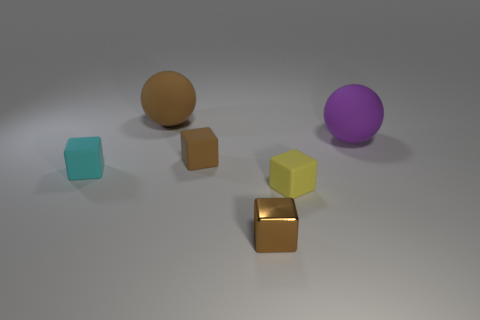Subtract 1 blocks. How many blocks are left? 3 Subtract all gray cubes. Subtract all gray spheres. How many cubes are left? 4 Add 4 gray shiny things. How many objects exist? 10 Subtract all balls. How many objects are left? 4 Subtract 1 brown blocks. How many objects are left? 5 Subtract all yellow rubber blocks. Subtract all big brown rubber things. How many objects are left? 4 Add 1 yellow matte cubes. How many yellow matte cubes are left? 2 Add 2 large purple matte things. How many large purple matte things exist? 3 